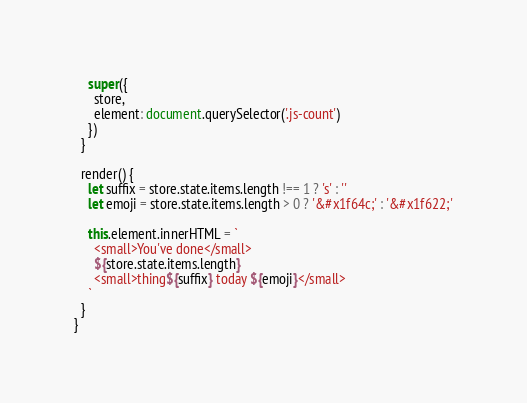Convert code to text. <code><loc_0><loc_0><loc_500><loc_500><_JavaScript_>    super({
      store,
      element: document.querySelector('.js-count')
    })
  }

  render() {
    let suffix = store.state.items.length !== 1 ? 's' : ''
    let emoji = store.state.items.length > 0 ? '&#x1f64c;' : '&#x1f622;'

    this.element.innerHTML = `
      <small>You've done</small>
      ${store.state.items.length}
      <small>thing${suffix} today ${emoji}</small>
    `
  }
}
</code> 